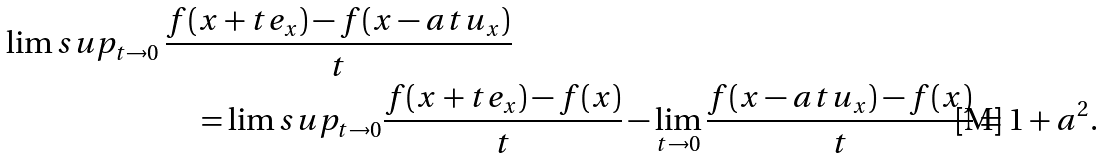Convert formula to latex. <formula><loc_0><loc_0><loc_500><loc_500>\lim s u p _ { t \to 0 } \, & \frac { f ( x + t e _ { x } ) - f ( x - a t u _ { x } ) } { t } \\ & \quad = \lim s u p _ { t \to 0 } \frac { f ( x + t e _ { x } ) - f ( x ) } { t } - \lim _ { t \to 0 } \frac { f ( x - { a t } u _ { x } ) - f ( x ) } { t } = 1 + a ^ { 2 } .</formula> 